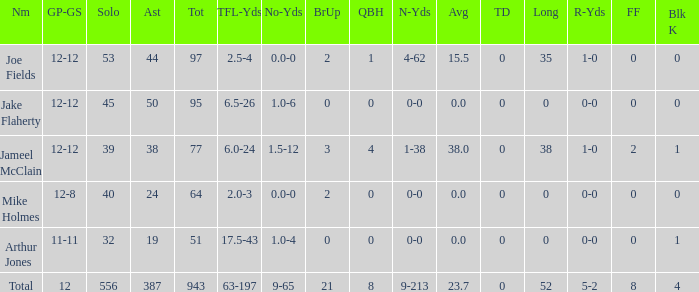How many yards for the player with tfl-yds of 2.5-4? 4-62. 